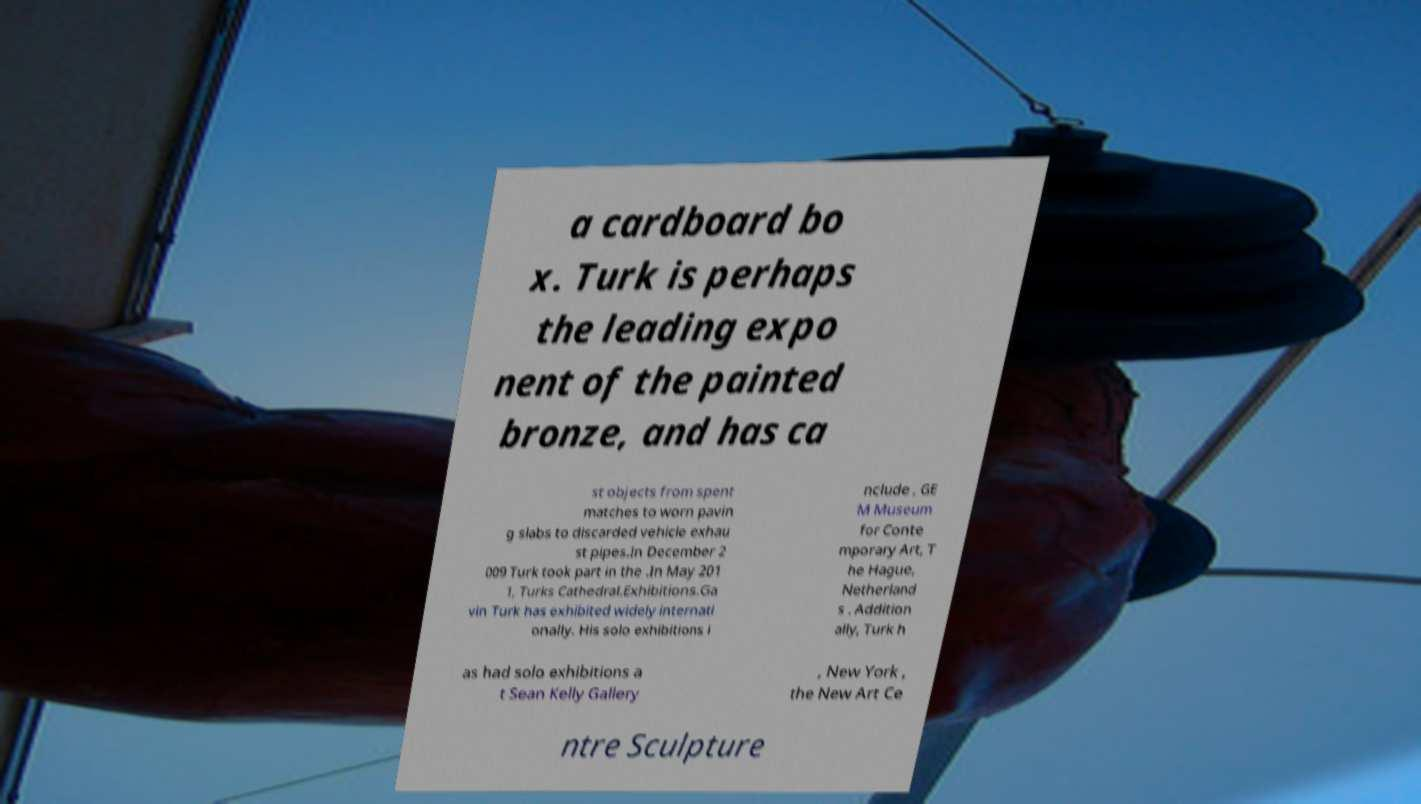Could you extract and type out the text from this image? a cardboard bo x. Turk is perhaps the leading expo nent of the painted bronze, and has ca st objects from spent matches to worn pavin g slabs to discarded vehicle exhau st pipes.In December 2 009 Turk took part in the .In May 201 1, Turks Cathedral.Exhibitions.Ga vin Turk has exhibited widely internati onally. His solo exhibitions i nclude , GE M Museum for Conte mporary Art, T he Hague, Netherland s . Addition ally, Turk h as had solo exhibitions a t Sean Kelly Gallery , New York , the New Art Ce ntre Sculpture 